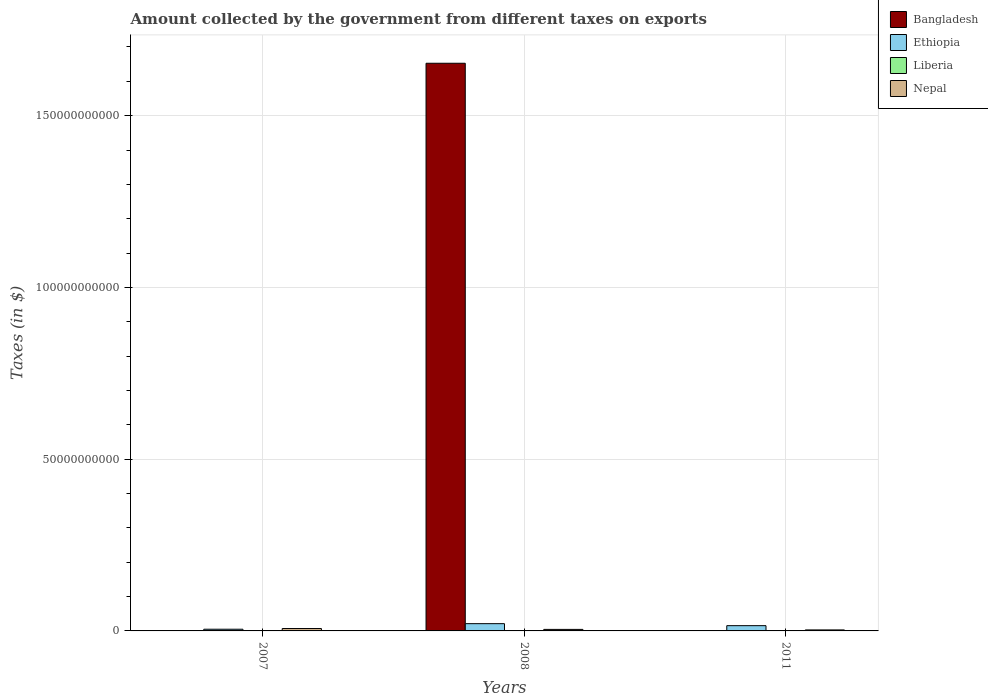Are the number of bars per tick equal to the number of legend labels?
Offer a very short reply. Yes. Are the number of bars on each tick of the X-axis equal?
Keep it short and to the point. Yes. How many bars are there on the 3rd tick from the left?
Your response must be concise. 4. How many bars are there on the 2nd tick from the right?
Offer a terse response. 4. What is the amount collected by the government from taxes on exports in Ethiopia in 2008?
Your response must be concise. 2.11e+09. Across all years, what is the maximum amount collected by the government from taxes on exports in Liberia?
Provide a succinct answer. 2.67e+04. Across all years, what is the minimum amount collected by the government from taxes on exports in Liberia?
Keep it short and to the point. 1.54e+04. In which year was the amount collected by the government from taxes on exports in Nepal minimum?
Keep it short and to the point. 2011. What is the total amount collected by the government from taxes on exports in Nepal in the graph?
Give a very brief answer. 1.44e+09. What is the difference between the amount collected by the government from taxes on exports in Nepal in 2008 and that in 2011?
Offer a very short reply. 1.53e+08. What is the difference between the amount collected by the government from taxes on exports in Bangladesh in 2011 and the amount collected by the government from taxes on exports in Nepal in 2008?
Provide a short and direct response. -4.46e+08. What is the average amount collected by the government from taxes on exports in Liberia per year?
Give a very brief answer. 2.10e+04. In the year 2008, what is the difference between the amount collected by the government from taxes on exports in Liberia and amount collected by the government from taxes on exports in Bangladesh?
Offer a very short reply. -1.65e+11. In how many years, is the amount collected by the government from taxes on exports in Liberia greater than 80000000000 $?
Provide a short and direct response. 0. What is the ratio of the amount collected by the government from taxes on exports in Ethiopia in 2008 to that in 2011?
Keep it short and to the point. 1.38. Is the amount collected by the government from taxes on exports in Liberia in 2008 less than that in 2011?
Give a very brief answer. Yes. What is the difference between the highest and the second highest amount collected by the government from taxes on exports in Bangladesh?
Offer a very short reply. 1.65e+11. What is the difference between the highest and the lowest amount collected by the government from taxes on exports in Nepal?
Give a very brief answer. 4.06e+08. In how many years, is the amount collected by the government from taxes on exports in Bangladesh greater than the average amount collected by the government from taxes on exports in Bangladesh taken over all years?
Provide a short and direct response. 1. What does the 1st bar from the left in 2011 represents?
Ensure brevity in your answer.  Bangladesh. What does the 1st bar from the right in 2008 represents?
Your answer should be compact. Nepal. How many bars are there?
Provide a succinct answer. 12. Are all the bars in the graph horizontal?
Your answer should be very brief. No. How many years are there in the graph?
Make the answer very short. 3. What is the difference between two consecutive major ticks on the Y-axis?
Your answer should be compact. 5.00e+1. How many legend labels are there?
Provide a succinct answer. 4. What is the title of the graph?
Ensure brevity in your answer.  Amount collected by the government from different taxes on exports. Does "Oman" appear as one of the legend labels in the graph?
Make the answer very short. No. What is the label or title of the X-axis?
Your answer should be very brief. Years. What is the label or title of the Y-axis?
Your answer should be compact. Taxes (in $). What is the Taxes (in $) in Bangladesh in 2007?
Your response must be concise. 3.38e+05. What is the Taxes (in $) in Ethiopia in 2007?
Ensure brevity in your answer.  4.93e+08. What is the Taxes (in $) of Liberia in 2007?
Your response must be concise. 2.11e+04. What is the Taxes (in $) of Nepal in 2007?
Your response must be concise. 6.99e+08. What is the Taxes (in $) in Bangladesh in 2008?
Provide a succinct answer. 1.65e+11. What is the Taxes (in $) of Ethiopia in 2008?
Offer a very short reply. 2.11e+09. What is the Taxes (in $) in Liberia in 2008?
Your answer should be very brief. 1.54e+04. What is the Taxes (in $) in Nepal in 2008?
Keep it short and to the point. 4.46e+08. What is the Taxes (in $) in Bangladesh in 2011?
Keep it short and to the point. 8000. What is the Taxes (in $) of Ethiopia in 2011?
Your answer should be compact. 1.53e+09. What is the Taxes (in $) of Liberia in 2011?
Offer a very short reply. 2.67e+04. What is the Taxes (in $) of Nepal in 2011?
Provide a short and direct response. 2.92e+08. Across all years, what is the maximum Taxes (in $) in Bangladesh?
Offer a very short reply. 1.65e+11. Across all years, what is the maximum Taxes (in $) in Ethiopia?
Your response must be concise. 2.11e+09. Across all years, what is the maximum Taxes (in $) of Liberia?
Provide a succinct answer. 2.67e+04. Across all years, what is the maximum Taxes (in $) in Nepal?
Ensure brevity in your answer.  6.99e+08. Across all years, what is the minimum Taxes (in $) in Bangladesh?
Keep it short and to the point. 8000. Across all years, what is the minimum Taxes (in $) in Ethiopia?
Your answer should be compact. 4.93e+08. Across all years, what is the minimum Taxes (in $) in Liberia?
Make the answer very short. 1.54e+04. Across all years, what is the minimum Taxes (in $) of Nepal?
Make the answer very short. 2.92e+08. What is the total Taxes (in $) of Bangladesh in the graph?
Ensure brevity in your answer.  1.65e+11. What is the total Taxes (in $) of Ethiopia in the graph?
Ensure brevity in your answer.  4.14e+09. What is the total Taxes (in $) of Liberia in the graph?
Offer a very short reply. 6.31e+04. What is the total Taxes (in $) of Nepal in the graph?
Provide a short and direct response. 1.44e+09. What is the difference between the Taxes (in $) in Bangladesh in 2007 and that in 2008?
Keep it short and to the point. -1.65e+11. What is the difference between the Taxes (in $) of Ethiopia in 2007 and that in 2008?
Provide a short and direct response. -1.62e+09. What is the difference between the Taxes (in $) in Liberia in 2007 and that in 2008?
Give a very brief answer. 5731.42. What is the difference between the Taxes (in $) of Nepal in 2007 and that in 2008?
Provide a succinct answer. 2.53e+08. What is the difference between the Taxes (in $) of Bangladesh in 2007 and that in 2011?
Offer a very short reply. 3.30e+05. What is the difference between the Taxes (in $) of Ethiopia in 2007 and that in 2011?
Your answer should be compact. -1.04e+09. What is the difference between the Taxes (in $) in Liberia in 2007 and that in 2011?
Your response must be concise. -5566.22. What is the difference between the Taxes (in $) in Nepal in 2007 and that in 2011?
Provide a short and direct response. 4.06e+08. What is the difference between the Taxes (in $) in Bangladesh in 2008 and that in 2011?
Keep it short and to the point. 1.65e+11. What is the difference between the Taxes (in $) of Ethiopia in 2008 and that in 2011?
Provide a succinct answer. 5.79e+08. What is the difference between the Taxes (in $) of Liberia in 2008 and that in 2011?
Keep it short and to the point. -1.13e+04. What is the difference between the Taxes (in $) in Nepal in 2008 and that in 2011?
Ensure brevity in your answer.  1.53e+08. What is the difference between the Taxes (in $) in Bangladesh in 2007 and the Taxes (in $) in Ethiopia in 2008?
Your answer should be very brief. -2.11e+09. What is the difference between the Taxes (in $) in Bangladesh in 2007 and the Taxes (in $) in Liberia in 2008?
Give a very brief answer. 3.23e+05. What is the difference between the Taxes (in $) of Bangladesh in 2007 and the Taxes (in $) of Nepal in 2008?
Your response must be concise. -4.45e+08. What is the difference between the Taxes (in $) in Ethiopia in 2007 and the Taxes (in $) in Liberia in 2008?
Offer a terse response. 4.93e+08. What is the difference between the Taxes (in $) in Ethiopia in 2007 and the Taxes (in $) in Nepal in 2008?
Ensure brevity in your answer.  4.75e+07. What is the difference between the Taxes (in $) in Liberia in 2007 and the Taxes (in $) in Nepal in 2008?
Your answer should be very brief. -4.46e+08. What is the difference between the Taxes (in $) in Bangladesh in 2007 and the Taxes (in $) in Ethiopia in 2011?
Offer a very short reply. -1.53e+09. What is the difference between the Taxes (in $) in Bangladesh in 2007 and the Taxes (in $) in Liberia in 2011?
Make the answer very short. 3.11e+05. What is the difference between the Taxes (in $) in Bangladesh in 2007 and the Taxes (in $) in Nepal in 2011?
Your answer should be compact. -2.92e+08. What is the difference between the Taxes (in $) in Ethiopia in 2007 and the Taxes (in $) in Liberia in 2011?
Your answer should be very brief. 4.93e+08. What is the difference between the Taxes (in $) in Ethiopia in 2007 and the Taxes (in $) in Nepal in 2011?
Give a very brief answer. 2.01e+08. What is the difference between the Taxes (in $) in Liberia in 2007 and the Taxes (in $) in Nepal in 2011?
Offer a terse response. -2.92e+08. What is the difference between the Taxes (in $) of Bangladesh in 2008 and the Taxes (in $) of Ethiopia in 2011?
Give a very brief answer. 1.64e+11. What is the difference between the Taxes (in $) in Bangladesh in 2008 and the Taxes (in $) in Liberia in 2011?
Your answer should be compact. 1.65e+11. What is the difference between the Taxes (in $) in Bangladesh in 2008 and the Taxes (in $) in Nepal in 2011?
Your answer should be compact. 1.65e+11. What is the difference between the Taxes (in $) in Ethiopia in 2008 and the Taxes (in $) in Liberia in 2011?
Provide a succinct answer. 2.11e+09. What is the difference between the Taxes (in $) in Ethiopia in 2008 and the Taxes (in $) in Nepal in 2011?
Ensure brevity in your answer.  1.82e+09. What is the difference between the Taxes (in $) of Liberia in 2008 and the Taxes (in $) of Nepal in 2011?
Your answer should be compact. -2.92e+08. What is the average Taxes (in $) in Bangladesh per year?
Provide a short and direct response. 5.51e+1. What is the average Taxes (in $) in Ethiopia per year?
Provide a succinct answer. 1.38e+09. What is the average Taxes (in $) of Liberia per year?
Give a very brief answer. 2.10e+04. What is the average Taxes (in $) in Nepal per year?
Make the answer very short. 4.79e+08. In the year 2007, what is the difference between the Taxes (in $) of Bangladesh and Taxes (in $) of Ethiopia?
Provide a succinct answer. -4.93e+08. In the year 2007, what is the difference between the Taxes (in $) in Bangladesh and Taxes (in $) in Liberia?
Offer a very short reply. 3.17e+05. In the year 2007, what is the difference between the Taxes (in $) in Bangladesh and Taxes (in $) in Nepal?
Ensure brevity in your answer.  -6.98e+08. In the year 2007, what is the difference between the Taxes (in $) of Ethiopia and Taxes (in $) of Liberia?
Provide a succinct answer. 4.93e+08. In the year 2007, what is the difference between the Taxes (in $) in Ethiopia and Taxes (in $) in Nepal?
Provide a succinct answer. -2.06e+08. In the year 2007, what is the difference between the Taxes (in $) of Liberia and Taxes (in $) of Nepal?
Keep it short and to the point. -6.99e+08. In the year 2008, what is the difference between the Taxes (in $) of Bangladesh and Taxes (in $) of Ethiopia?
Provide a succinct answer. 1.63e+11. In the year 2008, what is the difference between the Taxes (in $) in Bangladesh and Taxes (in $) in Liberia?
Your response must be concise. 1.65e+11. In the year 2008, what is the difference between the Taxes (in $) in Bangladesh and Taxes (in $) in Nepal?
Your answer should be very brief. 1.65e+11. In the year 2008, what is the difference between the Taxes (in $) of Ethiopia and Taxes (in $) of Liberia?
Offer a terse response. 2.11e+09. In the year 2008, what is the difference between the Taxes (in $) in Ethiopia and Taxes (in $) in Nepal?
Provide a succinct answer. 1.67e+09. In the year 2008, what is the difference between the Taxes (in $) in Liberia and Taxes (in $) in Nepal?
Your answer should be very brief. -4.46e+08. In the year 2011, what is the difference between the Taxes (in $) of Bangladesh and Taxes (in $) of Ethiopia?
Give a very brief answer. -1.53e+09. In the year 2011, what is the difference between the Taxes (in $) of Bangladesh and Taxes (in $) of Liberia?
Give a very brief answer. -1.87e+04. In the year 2011, what is the difference between the Taxes (in $) in Bangladesh and Taxes (in $) in Nepal?
Provide a succinct answer. -2.92e+08. In the year 2011, what is the difference between the Taxes (in $) in Ethiopia and Taxes (in $) in Liberia?
Your answer should be very brief. 1.53e+09. In the year 2011, what is the difference between the Taxes (in $) of Ethiopia and Taxes (in $) of Nepal?
Offer a very short reply. 1.24e+09. In the year 2011, what is the difference between the Taxes (in $) in Liberia and Taxes (in $) in Nepal?
Provide a short and direct response. -2.92e+08. What is the ratio of the Taxes (in $) of Bangladesh in 2007 to that in 2008?
Your answer should be compact. 0. What is the ratio of the Taxes (in $) in Ethiopia in 2007 to that in 2008?
Your answer should be very brief. 0.23. What is the ratio of the Taxes (in $) in Liberia in 2007 to that in 2008?
Your answer should be compact. 1.37. What is the ratio of the Taxes (in $) of Nepal in 2007 to that in 2008?
Your answer should be compact. 1.57. What is the ratio of the Taxes (in $) of Bangladesh in 2007 to that in 2011?
Offer a very short reply. 42.25. What is the ratio of the Taxes (in $) of Ethiopia in 2007 to that in 2011?
Ensure brevity in your answer.  0.32. What is the ratio of the Taxes (in $) of Liberia in 2007 to that in 2011?
Make the answer very short. 0.79. What is the ratio of the Taxes (in $) in Nepal in 2007 to that in 2011?
Provide a short and direct response. 2.39. What is the ratio of the Taxes (in $) in Bangladesh in 2008 to that in 2011?
Offer a very short reply. 2.07e+07. What is the ratio of the Taxes (in $) of Ethiopia in 2008 to that in 2011?
Your response must be concise. 1.38. What is the ratio of the Taxes (in $) of Liberia in 2008 to that in 2011?
Your response must be concise. 0.58. What is the ratio of the Taxes (in $) in Nepal in 2008 to that in 2011?
Offer a very short reply. 1.52. What is the difference between the highest and the second highest Taxes (in $) in Bangladesh?
Your response must be concise. 1.65e+11. What is the difference between the highest and the second highest Taxes (in $) in Ethiopia?
Provide a short and direct response. 5.79e+08. What is the difference between the highest and the second highest Taxes (in $) in Liberia?
Offer a terse response. 5566.22. What is the difference between the highest and the second highest Taxes (in $) in Nepal?
Ensure brevity in your answer.  2.53e+08. What is the difference between the highest and the lowest Taxes (in $) of Bangladesh?
Your response must be concise. 1.65e+11. What is the difference between the highest and the lowest Taxes (in $) of Ethiopia?
Your answer should be compact. 1.62e+09. What is the difference between the highest and the lowest Taxes (in $) of Liberia?
Make the answer very short. 1.13e+04. What is the difference between the highest and the lowest Taxes (in $) of Nepal?
Ensure brevity in your answer.  4.06e+08. 